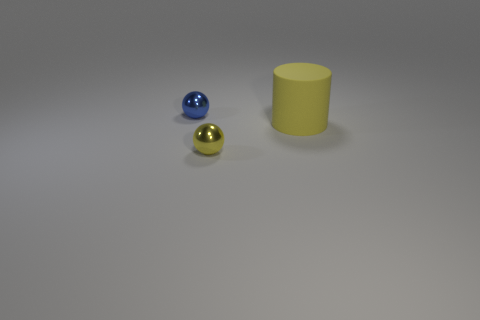Are there any other things that are the same material as the large yellow thing?
Ensure brevity in your answer.  No. What shape is the metal thing right of the blue ball?
Make the answer very short. Sphere. How many tiny green spheres have the same material as the tiny blue sphere?
Keep it short and to the point. 0. Does the blue metallic thing have the same shape as the yellow object that is in front of the matte object?
Your answer should be very brief. Yes. There is a object that is on the right side of the small ball that is to the right of the small blue object; is there a yellow object that is left of it?
Provide a succinct answer. Yes. There is a yellow thing behind the yellow ball; how big is it?
Your response must be concise. Large. There is another ball that is the same size as the blue ball; what is it made of?
Provide a succinct answer. Metal. Is the tiny yellow object the same shape as the small blue shiny object?
Make the answer very short. Yes. What number of things are large yellow matte cylinders or objects that are to the left of the large rubber cylinder?
Your answer should be very brief. 3. What material is the small thing that is the same color as the large thing?
Your response must be concise. Metal. 